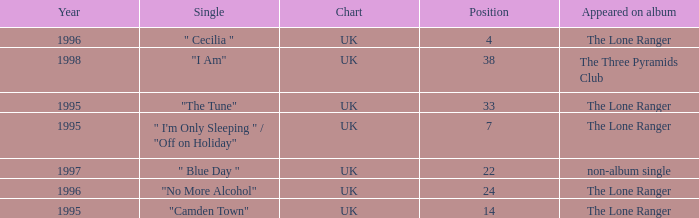After 1996, what is the average position? 30.0. 